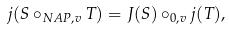Convert formula to latex. <formula><loc_0><loc_0><loc_500><loc_500>j ( S \circ _ { N A P , v } T ) = J ( S ) \circ _ { 0 , v } j ( T ) ,</formula> 